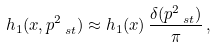Convert formula to latex. <formula><loc_0><loc_0><loc_500><loc_500>h _ { 1 } ( x , p _ { \ s t } ^ { 2 } ) \approx h _ { 1 } ( x ) \, \frac { \delta ( p _ { \ s t } ^ { 2 } ) } { \pi } \, ,</formula> 